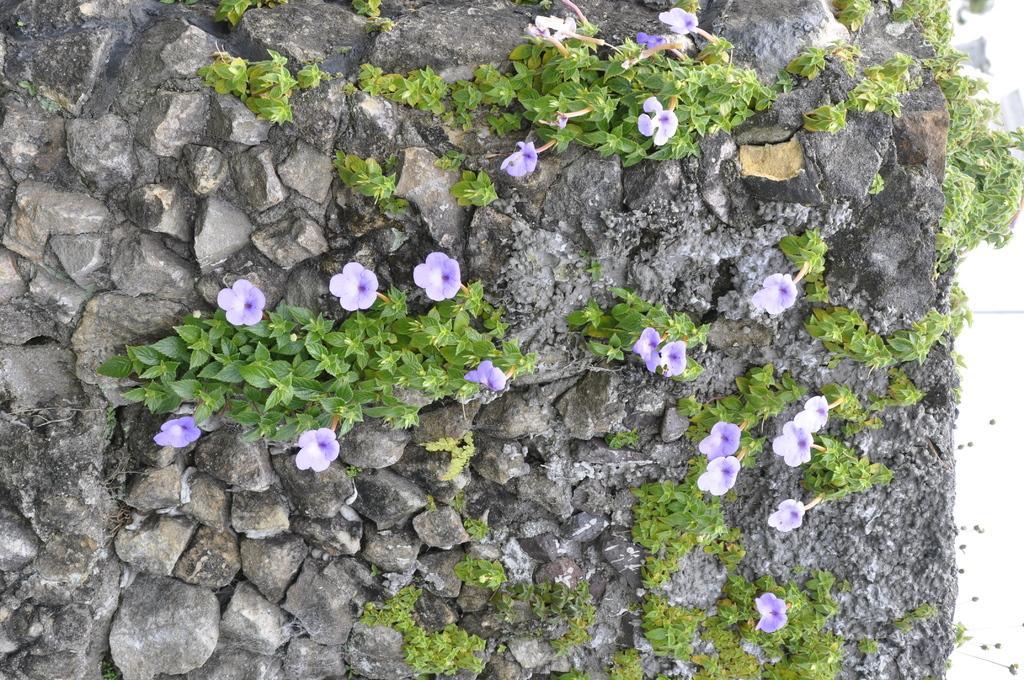How would you summarize this image in a sentence or two? This image is taken outdoors. In this image there are many rocks. There are a few creepers with stems, green leaves and a few flowers. Those flowers are lilac in color. 